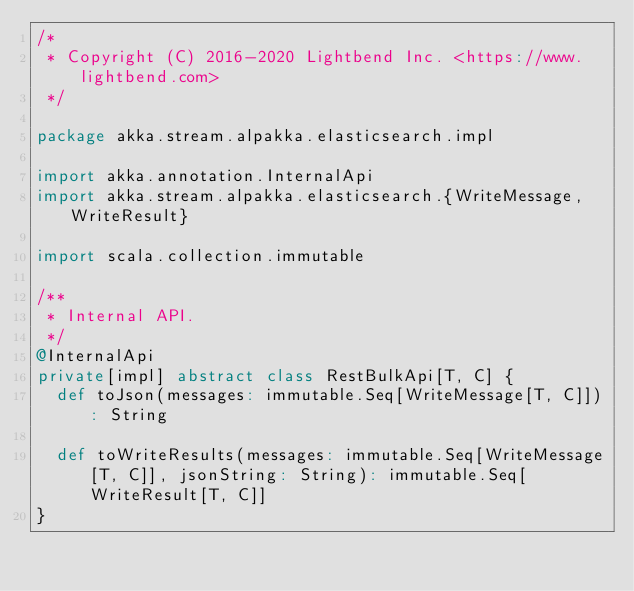Convert code to text. <code><loc_0><loc_0><loc_500><loc_500><_Scala_>/*
 * Copyright (C) 2016-2020 Lightbend Inc. <https://www.lightbend.com>
 */

package akka.stream.alpakka.elasticsearch.impl

import akka.annotation.InternalApi
import akka.stream.alpakka.elasticsearch.{WriteMessage, WriteResult}

import scala.collection.immutable

/**
 * Internal API.
 */
@InternalApi
private[impl] abstract class RestBulkApi[T, C] {
  def toJson(messages: immutable.Seq[WriteMessage[T, C]]): String

  def toWriteResults(messages: immutable.Seq[WriteMessage[T, C]], jsonString: String): immutable.Seq[WriteResult[T, C]]
}
</code> 